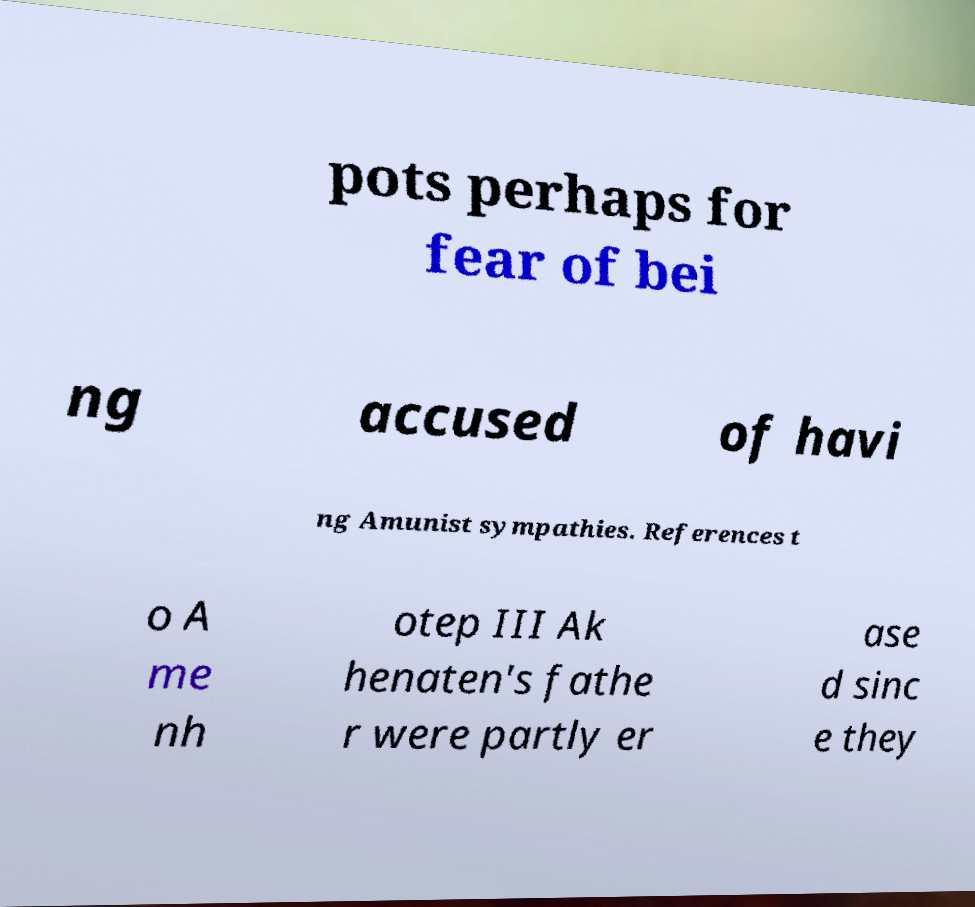Could you extract and type out the text from this image? pots perhaps for fear of bei ng accused of havi ng Amunist sympathies. References t o A me nh otep III Ak henaten's fathe r were partly er ase d sinc e they 